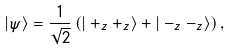<formula> <loc_0><loc_0><loc_500><loc_500>| \psi \rangle = \frac { 1 } { \sqrt { 2 } } \left ( | + _ { z } + _ { z } \rangle + | - _ { z } - _ { z } \rangle \right ) ,</formula> 